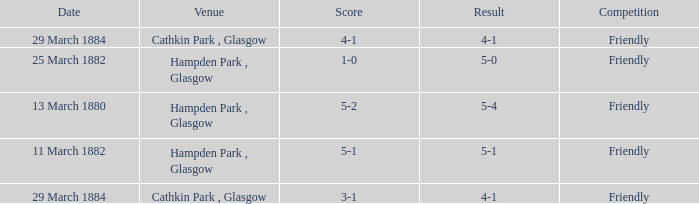Which item has a score of 5-1? 5-1. 